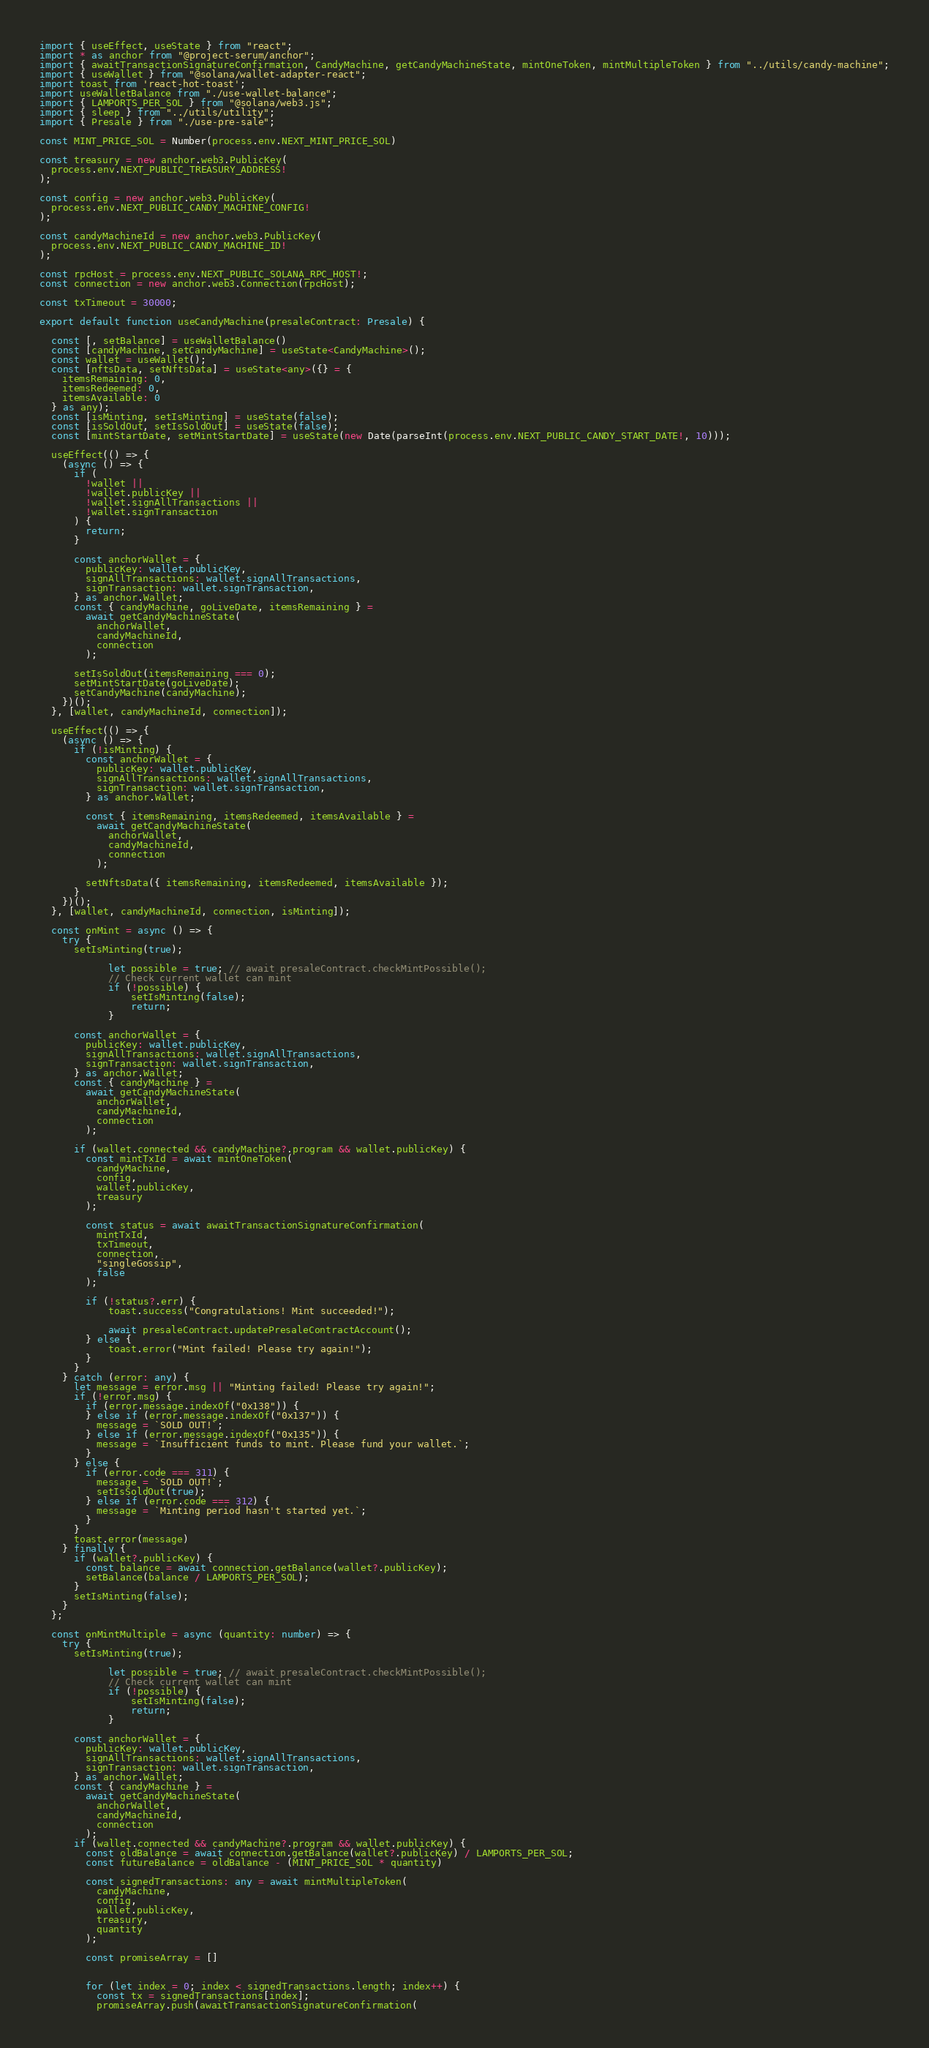<code> <loc_0><loc_0><loc_500><loc_500><_TypeScript_>import { useEffect, useState } from "react";
import * as anchor from "@project-serum/anchor";
import { awaitTransactionSignatureConfirmation, CandyMachine, getCandyMachineState, mintOneToken, mintMultipleToken } from "../utils/candy-machine";
import { useWallet } from "@solana/wallet-adapter-react";
import toast from 'react-hot-toast';
import useWalletBalance from "./use-wallet-balance";
import { LAMPORTS_PER_SOL } from "@solana/web3.js";
import { sleep } from "../utils/utility";
import { Presale } from "./use-pre-sale";

const MINT_PRICE_SOL = Number(process.env.NEXT_MINT_PRICE_SOL)

const treasury = new anchor.web3.PublicKey(
  process.env.NEXT_PUBLIC_TREASURY_ADDRESS!
);

const config = new anchor.web3.PublicKey(
  process.env.NEXT_PUBLIC_CANDY_MACHINE_CONFIG!
);

const candyMachineId = new anchor.web3.PublicKey(
  process.env.NEXT_PUBLIC_CANDY_MACHINE_ID!
);

const rpcHost = process.env.NEXT_PUBLIC_SOLANA_RPC_HOST!;
const connection = new anchor.web3.Connection(rpcHost);

const txTimeout = 30000;

export default function useCandyMachine(presaleContract: Presale) {

  const [, setBalance] = useWalletBalance()
  const [candyMachine, setCandyMachine] = useState<CandyMachine>();
  const wallet = useWallet();
  const [nftsData, setNftsData] = useState<any>({} = {
    itemsRemaining: 0,
    itemsRedeemed: 0,
    itemsAvailable: 0
  } as any);
  const [isMinting, setIsMinting] = useState(false);
  const [isSoldOut, setIsSoldOut] = useState(false);
  const [mintStartDate, setMintStartDate] = useState(new Date(parseInt(process.env.NEXT_PUBLIC_CANDY_START_DATE!, 10)));

  useEffect(() => {
    (async () => {
      if (
        !wallet ||
        !wallet.publicKey ||
        !wallet.signAllTransactions ||
        !wallet.signTransaction
      ) {
        return;
      }

      const anchorWallet = {
        publicKey: wallet.publicKey,
        signAllTransactions: wallet.signAllTransactions,
        signTransaction: wallet.signTransaction,
      } as anchor.Wallet;
      const { candyMachine, goLiveDate, itemsRemaining } =
        await getCandyMachineState(
          anchorWallet,
          candyMachineId,
          connection
        );

      setIsSoldOut(itemsRemaining === 0);
      setMintStartDate(goLiveDate);
      setCandyMachine(candyMachine);
    })();
  }, [wallet, candyMachineId, connection]);

  useEffect(() => {
    (async () => {
      if (!isMinting) {
        const anchorWallet = {
          publicKey: wallet.publicKey,
          signAllTransactions: wallet.signAllTransactions,
          signTransaction: wallet.signTransaction,
        } as anchor.Wallet;

        const { itemsRemaining, itemsRedeemed, itemsAvailable } =
          await getCandyMachineState(
            anchorWallet,
            candyMachineId,
            connection
          );

        setNftsData({ itemsRemaining, itemsRedeemed, itemsAvailable });
      }
    })();
  }, [wallet, candyMachineId, connection, isMinting]);

  const onMint = async () => {
    try {
      setIsMinting(true);

			let possible = true; // await presaleContract.checkMintPossible();
			// Check current wallet can mint
			if (!possible) {
				setIsMinting(false);
				return;
			}

      const anchorWallet = {
        publicKey: wallet.publicKey,
        signAllTransactions: wallet.signAllTransactions,
        signTransaction: wallet.signTransaction,
      } as anchor.Wallet;
      const { candyMachine } =
        await getCandyMachineState(
          anchorWallet,
          candyMachineId,
          connection
        );

      if (wallet.connected && candyMachine?.program && wallet.publicKey) {
        const mintTxId = await mintOneToken(
          candyMachine,
          config,
          wallet.publicKey,
          treasury
        );

        const status = await awaitTransactionSignatureConfirmation(
          mintTxId,
          txTimeout,
          connection,
          "singleGossip",
          false
        );

        if (!status?.err) {
			toast.success("Congratulations! Mint succeeded!");

			await presaleContract.updatePresaleContractAccount();
        } else {
			toast.error("Mint failed! Please try again!");
        }
      }
    } catch (error: any) {
      let message = error.msg || "Minting failed! Please try again!";
      if (!error.msg) {
        if (error.message.indexOf("0x138")) {
        } else if (error.message.indexOf("0x137")) {
          message = `SOLD OUT!`;
        } else if (error.message.indexOf("0x135")) {
          message = `Insufficient funds to mint. Please fund your wallet.`;
        }
      } else {
        if (error.code === 311) {
          message = `SOLD OUT!`;
          setIsSoldOut(true);
        } else if (error.code === 312) {
          message = `Minting period hasn't started yet.`;
        }
      }
      toast.error(message)
    } finally {
      if (wallet?.publicKey) {
        const balance = await connection.getBalance(wallet?.publicKey);
        setBalance(balance / LAMPORTS_PER_SOL);
      }
      setIsMinting(false);
    }
  };

  const onMintMultiple = async (quantity: number) => {
    try {
      setIsMinting(true);

			let possible = true; // await presaleContract.checkMintPossible();
			// Check current wallet can mint
			if (!possible) {
				setIsMinting(false);
				return;
			}

      const anchorWallet = {
        publicKey: wallet.publicKey,
        signAllTransactions: wallet.signAllTransactions,
        signTransaction: wallet.signTransaction,
      } as anchor.Wallet;
      const { candyMachine } =
        await getCandyMachineState(
          anchorWallet,
          candyMachineId,
          connection
        );
      if (wallet.connected && candyMachine?.program && wallet.publicKey) {
        const oldBalance = await connection.getBalance(wallet?.publicKey) / LAMPORTS_PER_SOL;
        const futureBalance = oldBalance - (MINT_PRICE_SOL * quantity)

        const signedTransactions: any = await mintMultipleToken(
          candyMachine,
          config,
          wallet.publicKey,
          treasury,
          quantity
        );

        const promiseArray = []
        

        for (let index = 0; index < signedTransactions.length; index++) {
          const tx = signedTransactions[index];
          promiseArray.push(awaitTransactionSignatureConfirmation(</code> 